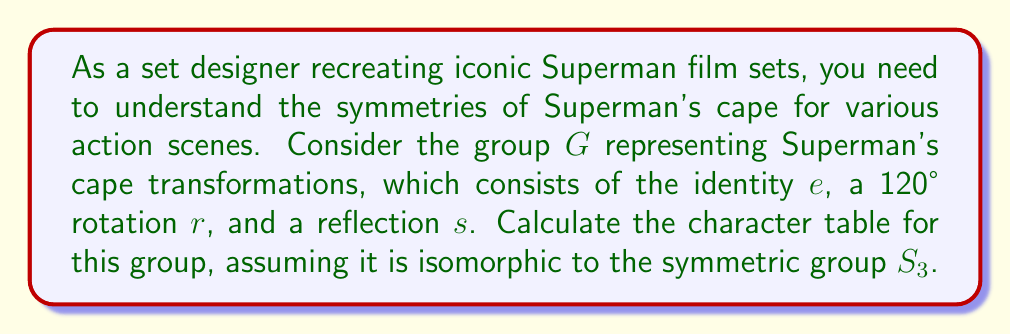Teach me how to tackle this problem. 1) First, identify the conjugacy classes of $G$:
   - $\{e\}$ (identity)
   - $\{r, r^2\}$ (120° rotations)
   - $\{s, rs, r^2s\}$ (reflections)

2) The number of irreducible representations equals the number of conjugacy classes, which is 3.

3) We know that $G$ is isomorphic to $S_3$, so it has order 6. The dimensions of the irreducible representations must satisfy:
   $1^2 + 1^2 + 2^2 = 6$

4) Therefore, we have two 1-dimensional representations and one 2-dimensional representation.

5) The trivial representation $\chi_1$ has character 1 for all elements.

6) The sign representation $\chi_2$ has character 1 for even permutations (e and rotations) and -1 for odd permutations (reflections).

7) For the 2-dimensional representation $\chi_3$:
   - $\chi_3(e) = 2$ (trace of 2x2 identity matrix)
   - $\chi_3(r) = -1$ (trace of 120° rotation matrix)
   - $\chi_3(s) = 0$ (trace of reflection matrix)

8) Construct the character table:

   $$\begin{array}{c|ccc}
      G & \{e\} & \{r,r^2\} & \{s,rs,r^2s\} \\
      \hline
      \chi_1 & 1 & 1 & 1 \\
      \chi_2 & 1 & 1 & -1 \\
      \chi_3 & 2 & -1 & 0
   \end{array}$$
Answer: $$\begin{array}{c|ccc}
   G & \{e\} & \{r,r^2\} & \{s,rs,r^2s\} \\
   \hline
   \chi_1 & 1 & 1 & 1 \\
   \chi_2 & 1 & 1 & -1 \\
   \chi_3 & 2 & -1 & 0
\end{array}$$ 